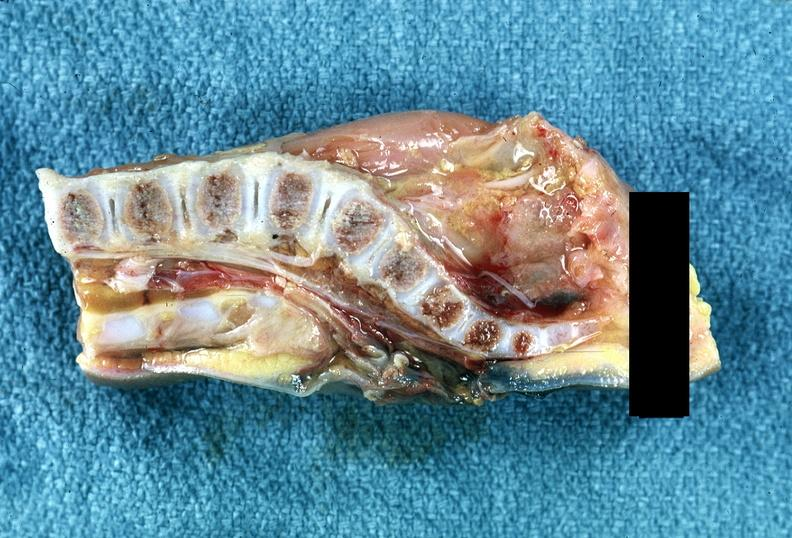what is present?
Answer the question using a single word or phrase. Nervous 